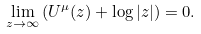<formula> <loc_0><loc_0><loc_500><loc_500>\lim _ { z \to \infty } \left ( U ^ { \mu } ( z ) + \log | z | \right ) = 0 .</formula> 